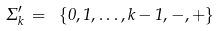Convert formula to latex. <formula><loc_0><loc_0><loc_500><loc_500>\Sigma ^ { \prime } _ { k } \, = \ \{ 0 , 1 , \dots , k - 1 , - , + \}</formula> 